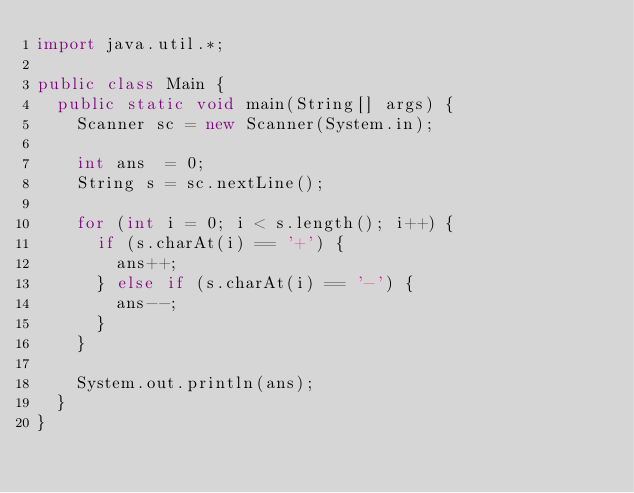Convert code to text. <code><loc_0><loc_0><loc_500><loc_500><_Java_>import java.util.*;

public class Main {
  public static void main(String[] args) {
    Scanner sc = new Scanner(System.in);
    
    int ans  = 0;
    String s = sc.nextLine();
    
    for (int i = 0; i < s.length(); i++) {
      if (s.charAt(i) == '+') {
        ans++;
      } else if (s.charAt(i) == '-') {
        ans--;
      }
    }
    
    System.out.println(ans);
  }
}</code> 